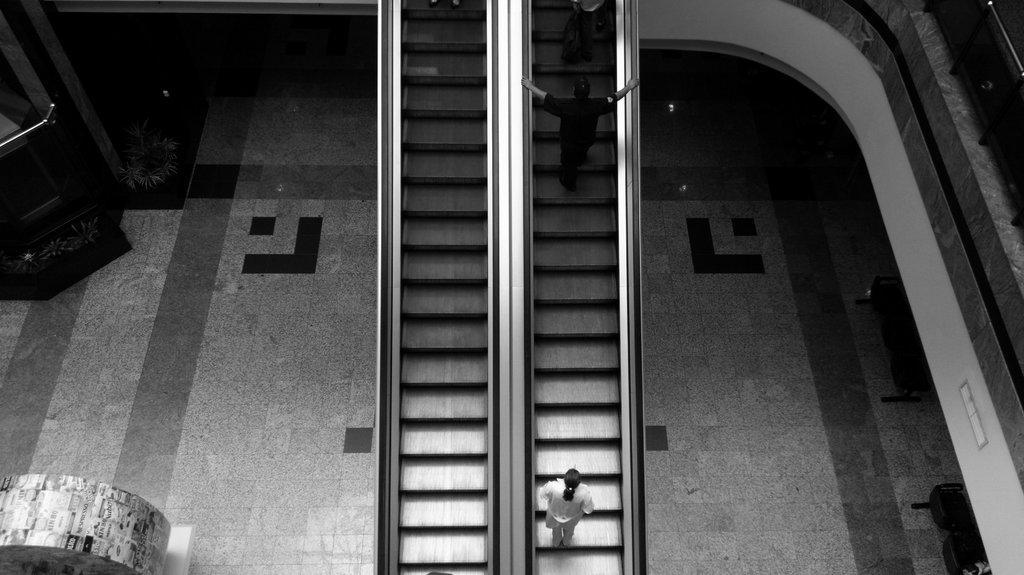Could you give a brief overview of what you see in this image? In this image in the middle there is an escalator and people are using it. 